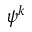Convert formula to latex. <formula><loc_0><loc_0><loc_500><loc_500>\psi ^ { k }</formula> 